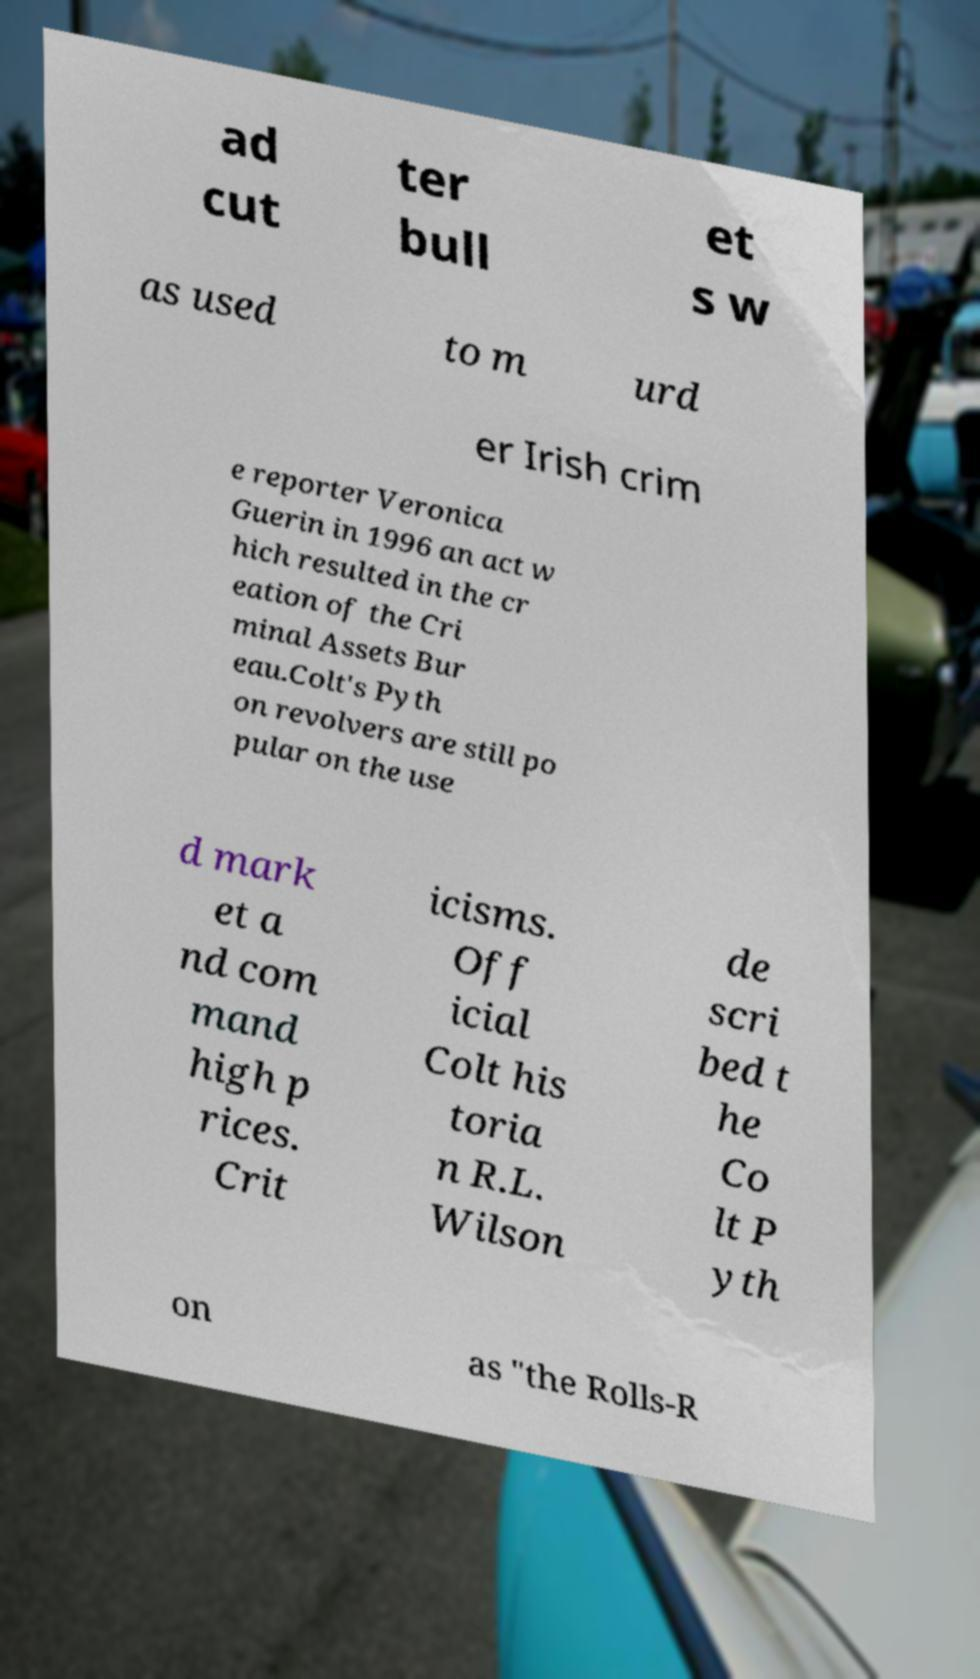Please read and relay the text visible in this image. What does it say? ad cut ter bull et s w as used to m urd er Irish crim e reporter Veronica Guerin in 1996 an act w hich resulted in the cr eation of the Cri minal Assets Bur eau.Colt's Pyth on revolvers are still po pular on the use d mark et a nd com mand high p rices. Crit icisms. Off icial Colt his toria n R.L. Wilson de scri bed t he Co lt P yth on as "the Rolls-R 